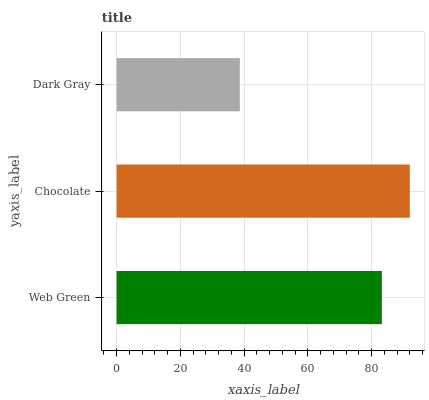Is Dark Gray the minimum?
Answer yes or no. Yes. Is Chocolate the maximum?
Answer yes or no. Yes. Is Chocolate the minimum?
Answer yes or no. No. Is Dark Gray the maximum?
Answer yes or no. No. Is Chocolate greater than Dark Gray?
Answer yes or no. Yes. Is Dark Gray less than Chocolate?
Answer yes or no. Yes. Is Dark Gray greater than Chocolate?
Answer yes or no. No. Is Chocolate less than Dark Gray?
Answer yes or no. No. Is Web Green the high median?
Answer yes or no. Yes. Is Web Green the low median?
Answer yes or no. Yes. Is Dark Gray the high median?
Answer yes or no. No. Is Chocolate the low median?
Answer yes or no. No. 